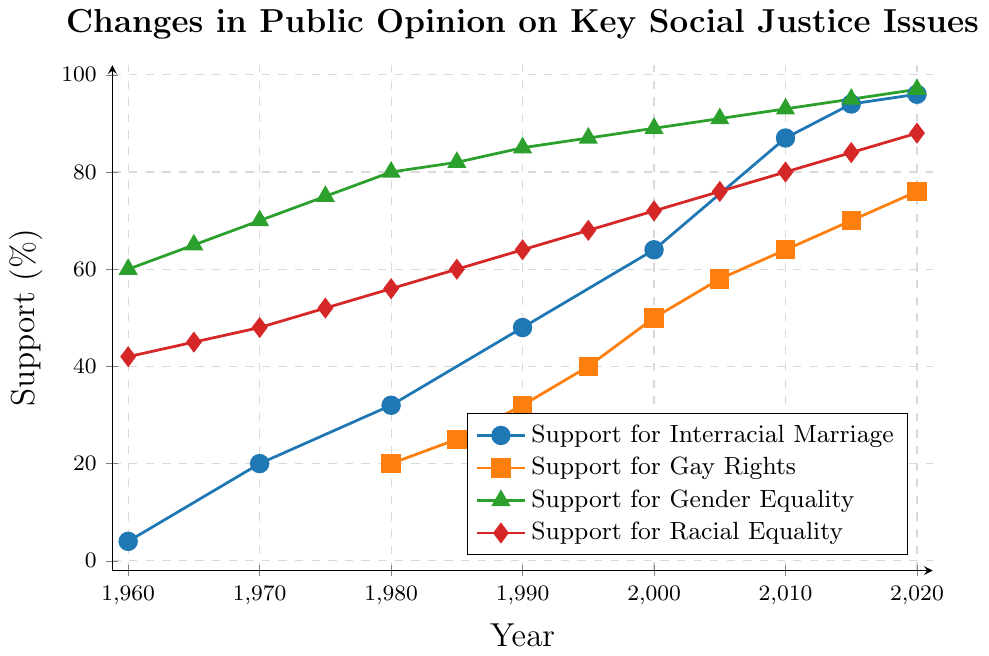What is the increase in support for interracial marriage from 1960 to 2020? To find the increase in support, subtract the support value in 1960 (4%) from the support value in 2020 (96%). The increase is therefore 96% - 4% = 92%.
Answer: 92% Which issue had the highest support in 2020? By looking at the support percentages in 2020 for all issues, Gender Equality had the highest support with 97%.
Answer: Gender Equality How does the support for racial equality in 1980 compare to support for gay rights in the same year? In 1980, the support for racial equality was 56%, while support for gay rights was 20%. Therefore, support for racial equality was higher in 1980.
Answer: Support for racial equality was higher Between which decades did the support for gender equality increase the most? By comparing the increases in support for gender equality across each decade, the biggest increase occurred between 1960 (60%) and 1970 (70%), which is a 10% increase.
Answer: 1960-1970 What is the average increase in support for gay rights from 1980 to 2020? To calculate this, subtract the 1980 support (20%) from the 2020 support (76%) to get an increase of 56%. Divide this by the 40 years between 1980 and 2020. So, the average increase per year is 56% / 40 ≈ 1.4%.
Answer: 1.4% What color represents the support for interracial marriage in the chart? In the chart, the line for support for interracial marriage is marked in blue.
Answer: Blue What trend is visible in the support for gender equality from 1960 to 2020? The support for gender equality consistently increased from 60% in 1960 to 97% in 2020 with almost no declines.
Answer: Consistent increase How much did support for racial equality increase between 2010 and 2020? Subtracting the 2010 value (80%) from the 2020 value (88%) shows an increase of 8%.
Answer: 8% By how much did the support for gay rights increase between 2000 and 2020? The support for gay rights was 50% in 2000 and 76% in 2020. The increase is 76% - 50% = 26%.
Answer: 26% Which issue showed the least variation in support from 1960 to 2020? Based on the visual data trends and changes, support for gender equality shows steady increases and therefore the least variation, consistently rising from 60% to 97%.
Answer: Gender Equality 